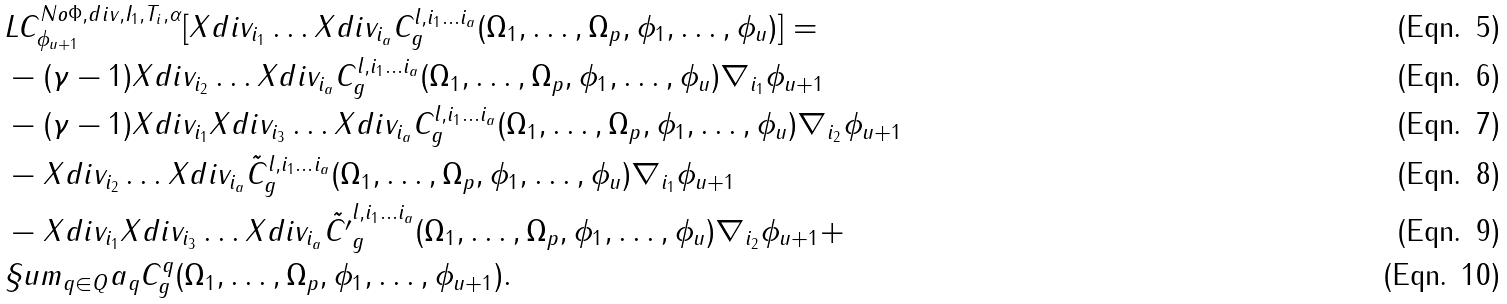<formula> <loc_0><loc_0><loc_500><loc_500>& L C ^ { N o \Phi , d i v , I _ { 1 } , T _ { i } , \alpha } _ { \phi _ { u + 1 } } [ X d i v _ { i _ { 1 } } \dots X d i v _ { i _ { a } } C ^ { l , i _ { 1 } \dots i _ { a } } _ { g } ( \Omega _ { 1 } , \dots , \Omega _ { p } , \phi _ { 1 } , \dots , \phi _ { u } ) ] = \\ & - ( \gamma - 1 ) X d i v _ { i _ { 2 } } \dots X d i v _ { i _ { a } } C ^ { l , i _ { 1 } \dots i _ { a } } _ { g } ( \Omega _ { 1 } , \dots , \Omega _ { p } , \phi _ { 1 } , \dots , \phi _ { u } ) \nabla _ { i _ { 1 } } \phi _ { u + 1 } \\ & - ( \gamma - 1 ) X d i v _ { i _ { 1 } } X d i v _ { i _ { 3 } } \dots X d i v _ { i _ { a } } C ^ { l , i _ { 1 } \dots i _ { a } } _ { g } ( \Omega _ { 1 } , \dots , \Omega _ { p } , \phi _ { 1 } , \dots , \phi _ { u } ) \nabla _ { i _ { 2 } } \phi _ { u + 1 } \\ & - X d i v _ { i _ { 2 } } \dots X d i v _ { i _ { a } } \tilde { C } ^ { l , i _ { 1 } \dots i _ { a } } _ { g } ( \Omega _ { 1 } , \dots , \Omega _ { p } , \phi _ { 1 } , \dots , \phi _ { u } ) \nabla _ { i _ { 1 } } \phi _ { u + 1 } \\ & - X d i v _ { i _ { 1 } } X d i v _ { i _ { 3 } } \dots X d i v _ { i _ { a } } \tilde { C ^ { \prime } } ^ { l , i _ { 1 } \dots i _ { a } } _ { g } ( \Omega _ { 1 } , \dots , \Omega _ { p } , \phi _ { 1 } , \dots , \phi _ { u } ) \nabla _ { i _ { 2 } } \phi _ { u + 1 } + \\ & \S u m _ { q \in Q } a _ { q } C ^ { q } _ { g } ( \Omega _ { 1 } , \dots , \Omega _ { p } , \phi _ { 1 } , \dots , \phi _ { u + 1 } ) .</formula> 